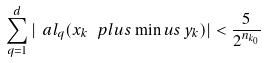Convert formula to latex. <formula><loc_0><loc_0><loc_500><loc_500>\sum _ { q = 1 } ^ { d } | \ a l _ { q } ( x _ { k } \, \ p l u s \min u s \, y _ { k } ) | < \frac { 5 } { 2 ^ { n _ { k _ { 0 } } } }</formula> 